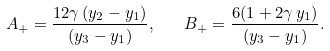Convert formula to latex. <formula><loc_0><loc_0><loc_500><loc_500>A _ { + } = \frac { 1 2 \gamma \, ( y _ { 2 } - y _ { 1 } ) } { ( y _ { 3 } - y _ { 1 } ) } , \quad B _ { + } = \frac { 6 ( 1 + 2 \gamma \, y _ { 1 } ) } { ( y _ { 3 } - y _ { 1 } ) } .</formula> 